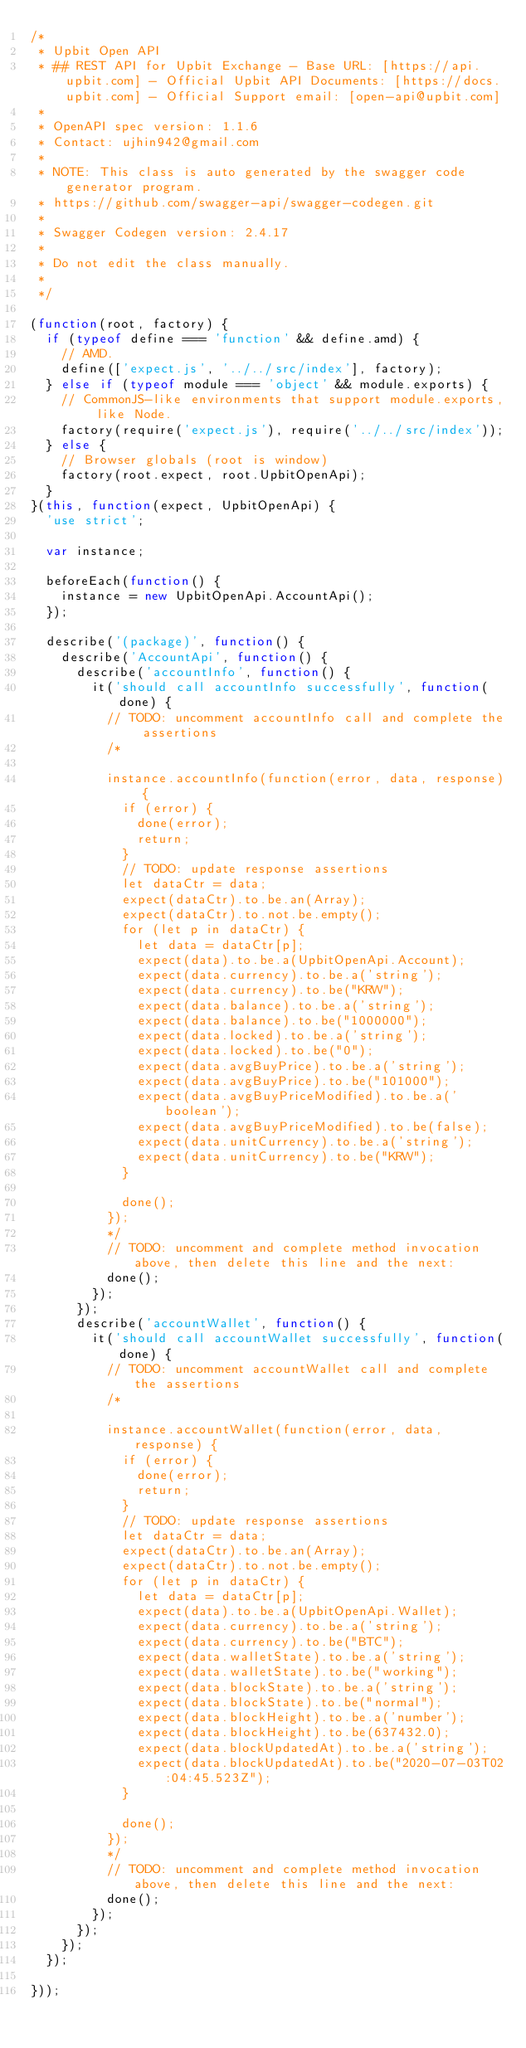Convert code to text. <code><loc_0><loc_0><loc_500><loc_500><_JavaScript_>/*
 * Upbit Open API
 * ## REST API for Upbit Exchange - Base URL: [https://api.upbit.com] - Official Upbit API Documents: [https://docs.upbit.com] - Official Support email: [open-api@upbit.com] 
 *
 * OpenAPI spec version: 1.1.6
 * Contact: ujhin942@gmail.com
 *
 * NOTE: This class is auto generated by the swagger code generator program.
 * https://github.com/swagger-api/swagger-codegen.git
 *
 * Swagger Codegen version: 2.4.17
 *
 * Do not edit the class manually.
 *
 */

(function(root, factory) {
  if (typeof define === 'function' && define.amd) {
    // AMD.
    define(['expect.js', '../../src/index'], factory);
  } else if (typeof module === 'object' && module.exports) {
    // CommonJS-like environments that support module.exports, like Node.
    factory(require('expect.js'), require('../../src/index'));
  } else {
    // Browser globals (root is window)
    factory(root.expect, root.UpbitOpenApi);
  }
}(this, function(expect, UpbitOpenApi) {
  'use strict';

  var instance;

  beforeEach(function() {
    instance = new UpbitOpenApi.AccountApi();
  });

  describe('(package)', function() {
    describe('AccountApi', function() {
      describe('accountInfo', function() {
        it('should call accountInfo successfully', function(done) {
          // TODO: uncomment accountInfo call and complete the assertions
          /*

          instance.accountInfo(function(error, data, response) {
            if (error) {
              done(error);
              return;
            }
            // TODO: update response assertions
            let dataCtr = data;
            expect(dataCtr).to.be.an(Array);
            expect(dataCtr).to.not.be.empty();
            for (let p in dataCtr) {
              let data = dataCtr[p];
              expect(data).to.be.a(UpbitOpenApi.Account);
              expect(data.currency).to.be.a('string');
              expect(data.currency).to.be("KRW");
              expect(data.balance).to.be.a('string');
              expect(data.balance).to.be("1000000");
              expect(data.locked).to.be.a('string');
              expect(data.locked).to.be("0");
              expect(data.avgBuyPrice).to.be.a('string');
              expect(data.avgBuyPrice).to.be("101000");
              expect(data.avgBuyPriceModified).to.be.a('boolean');
              expect(data.avgBuyPriceModified).to.be(false);
              expect(data.unitCurrency).to.be.a('string');
              expect(data.unitCurrency).to.be("KRW");
            }

            done();
          });
          */
          // TODO: uncomment and complete method invocation above, then delete this line and the next:
          done();
        });
      });
      describe('accountWallet', function() {
        it('should call accountWallet successfully', function(done) {
          // TODO: uncomment accountWallet call and complete the assertions
          /*

          instance.accountWallet(function(error, data, response) {
            if (error) {
              done(error);
              return;
            }
            // TODO: update response assertions
            let dataCtr = data;
            expect(dataCtr).to.be.an(Array);
            expect(dataCtr).to.not.be.empty();
            for (let p in dataCtr) {
              let data = dataCtr[p];
              expect(data).to.be.a(UpbitOpenApi.Wallet);
              expect(data.currency).to.be.a('string');
              expect(data.currency).to.be("BTC");
              expect(data.walletState).to.be.a('string');
              expect(data.walletState).to.be("working");
              expect(data.blockState).to.be.a('string');
              expect(data.blockState).to.be("normal");
              expect(data.blockHeight).to.be.a('number');
              expect(data.blockHeight).to.be(637432.0);
              expect(data.blockUpdatedAt).to.be.a('string');
              expect(data.blockUpdatedAt).to.be("2020-07-03T02:04:45.523Z");
            }

            done();
          });
          */
          // TODO: uncomment and complete method invocation above, then delete this line and the next:
          done();
        });
      });
    });
  });

}));
</code> 